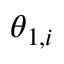Convert formula to latex. <formula><loc_0><loc_0><loc_500><loc_500>\theta _ { 1 , i }</formula> 